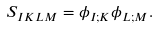Convert formula to latex. <formula><loc_0><loc_0><loc_500><loc_500>S _ { I K L M } = \phi _ { I ; K } \phi _ { L ; M } .</formula> 